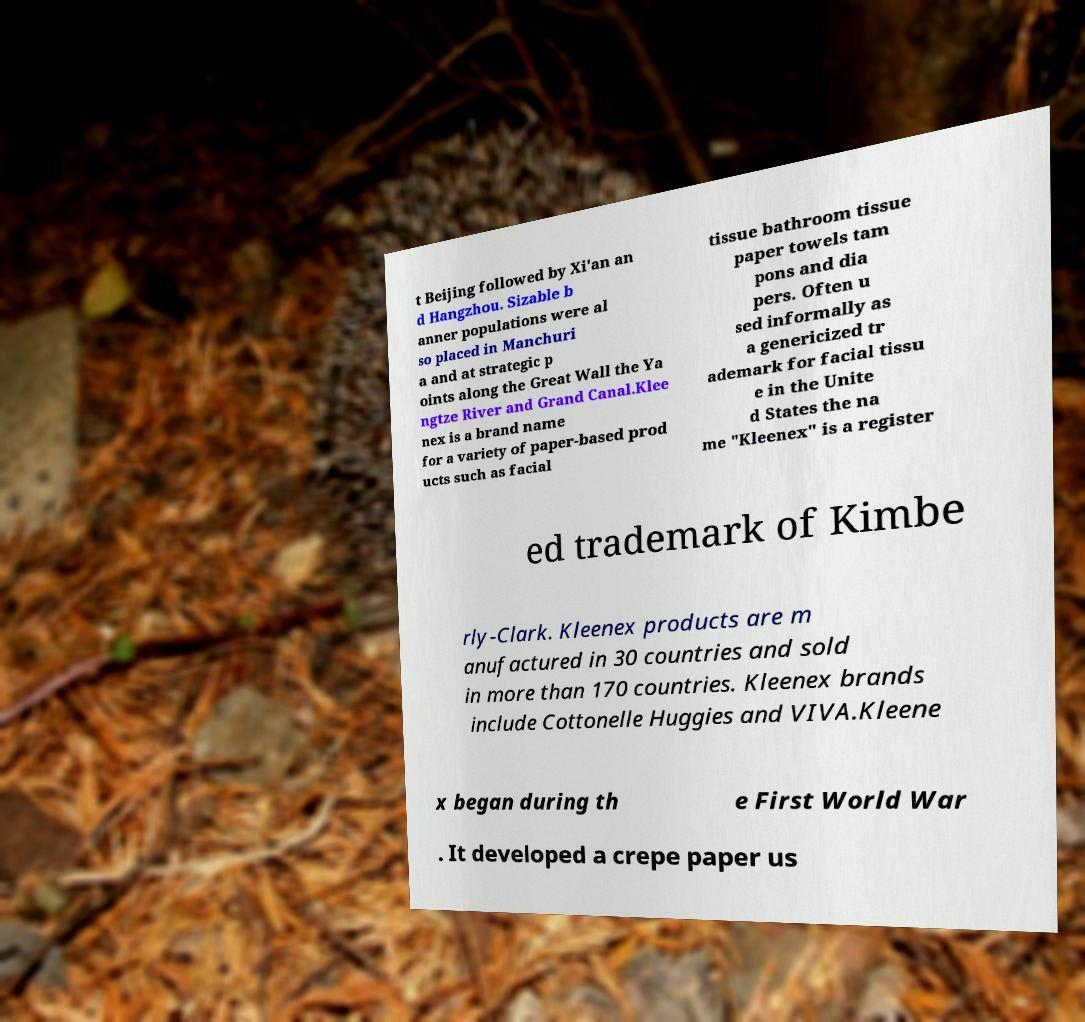Please read and relay the text visible in this image. What does it say? t Beijing followed by Xi'an an d Hangzhou. Sizable b anner populations were al so placed in Manchuri a and at strategic p oints along the Great Wall the Ya ngtze River and Grand Canal.Klee nex is a brand name for a variety of paper-based prod ucts such as facial tissue bathroom tissue paper towels tam pons and dia pers. Often u sed informally as a genericized tr ademark for facial tissu e in the Unite d States the na me "Kleenex" is a register ed trademark of Kimbe rly-Clark. Kleenex products are m anufactured in 30 countries and sold in more than 170 countries. Kleenex brands include Cottonelle Huggies and VIVA.Kleene x began during th e First World War . It developed a crepe paper us 